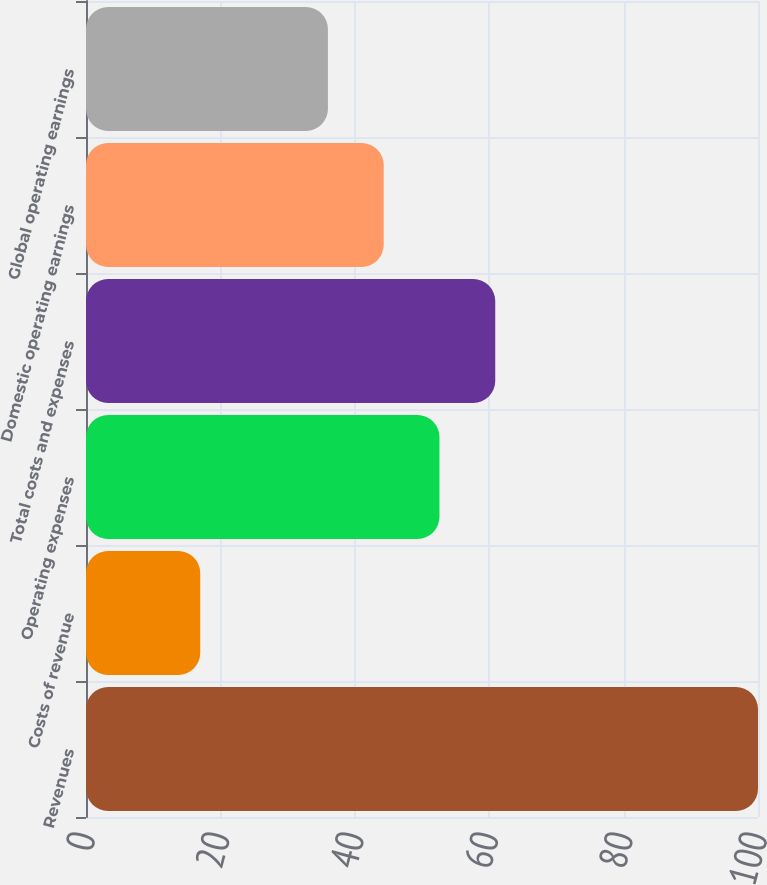Convert chart to OTSL. <chart><loc_0><loc_0><loc_500><loc_500><bar_chart><fcel>Revenues<fcel>Costs of revenue<fcel>Operating expenses<fcel>Total costs and expenses<fcel>Domestic operating earnings<fcel>Global operating earnings<nl><fcel>100<fcel>17<fcel>52.6<fcel>60.9<fcel>44.3<fcel>36<nl></chart> 